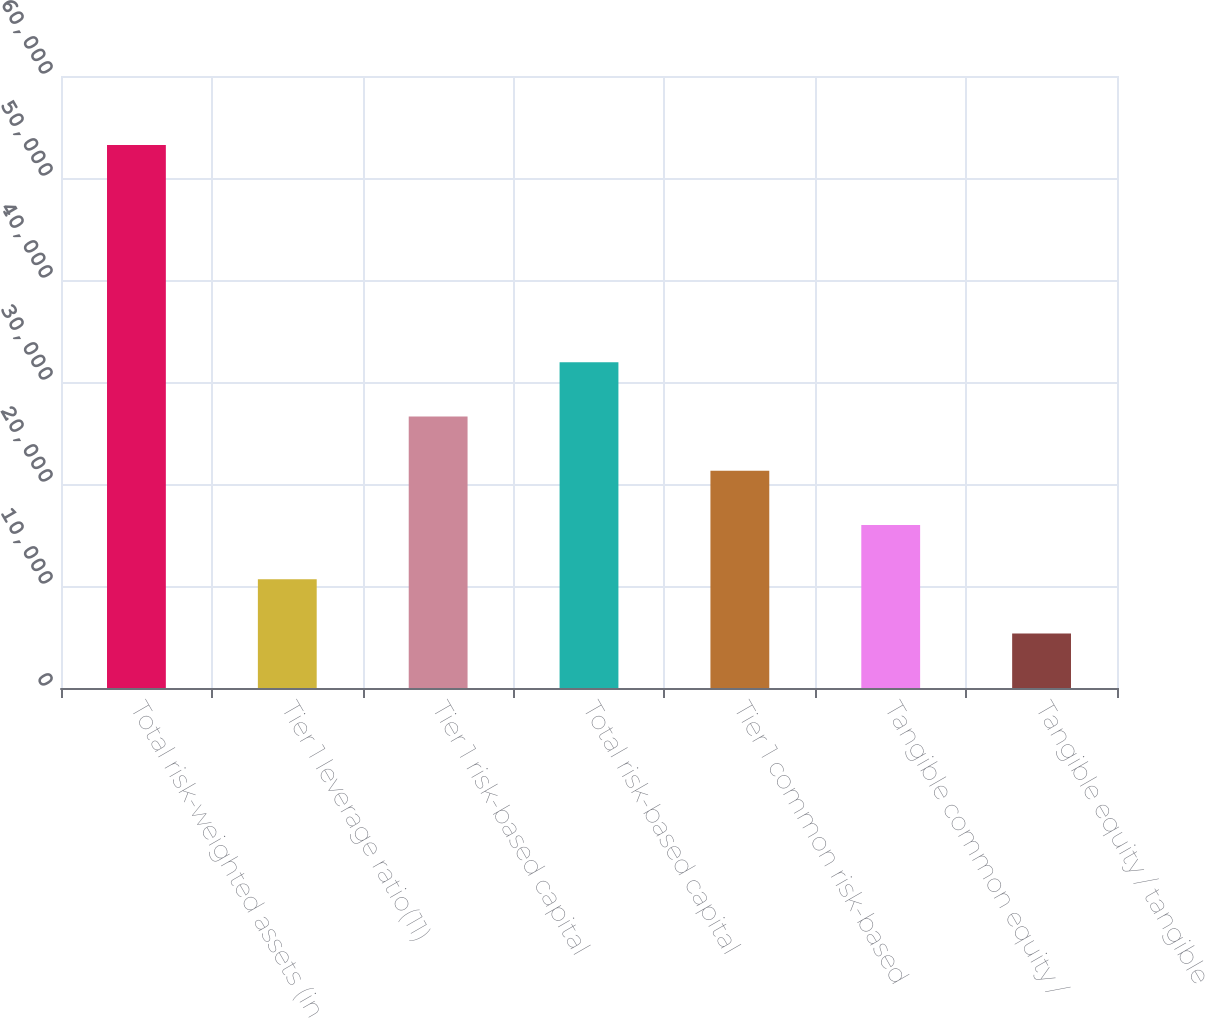Convert chart to OTSL. <chart><loc_0><loc_0><loc_500><loc_500><bar_chart><fcel>Total risk-weighted assets (in<fcel>Tier 1 leverage ratio(11)<fcel>Tier 1 risk-based capital<fcel>Total risk-based capital<fcel>Tier 1 common risk-based<fcel>Tangible common equity /<fcel>Tangible equity / tangible<nl><fcel>53239<fcel>10654.5<fcel>26623.7<fcel>31946.8<fcel>21300.6<fcel>15977.6<fcel>5331.42<nl></chart> 